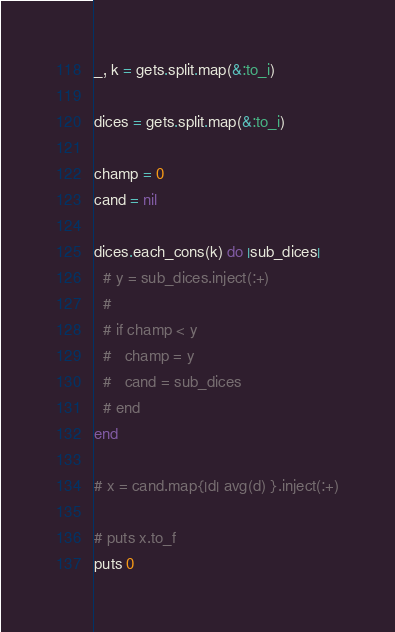<code> <loc_0><loc_0><loc_500><loc_500><_Ruby_>_, k = gets.split.map(&:to_i)

dices = gets.split.map(&:to_i)

champ = 0
cand = nil

dices.each_cons(k) do |sub_dices|
  # y = sub_dices.inject(:+)
  #
  # if champ < y
  #   champ = y
  #   cand = sub_dices
  # end
end

# x = cand.map{|d| avg(d) }.inject(:+)

# puts x.to_f
puts 0</code> 